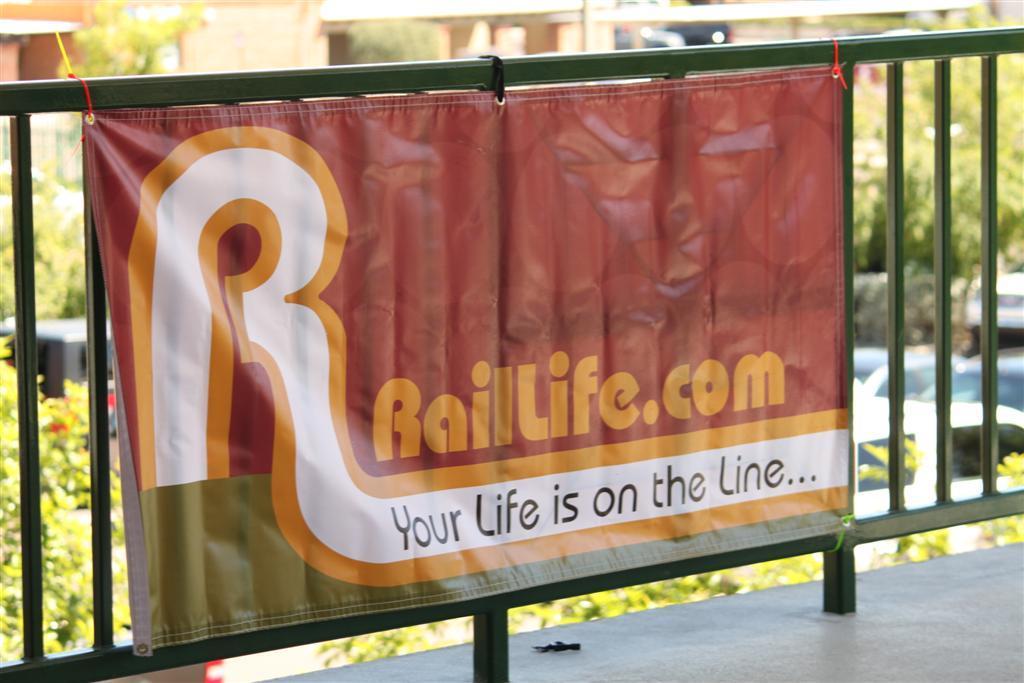What is on the line?
Offer a very short reply. Your life. What is the url in the picture?
Keep it short and to the point. Raillife.com. 